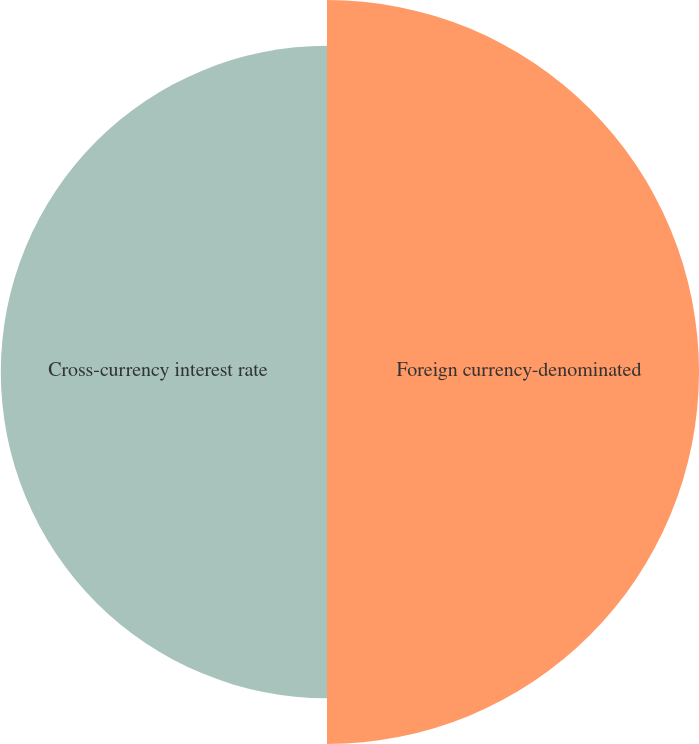Convert chart. <chart><loc_0><loc_0><loc_500><loc_500><pie_chart><fcel>Foreign currency-denominated<fcel>Cross-currency interest rate<nl><fcel>53.28%<fcel>46.72%<nl></chart> 